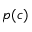Convert formula to latex. <formula><loc_0><loc_0><loc_500><loc_500>p ( c )</formula> 